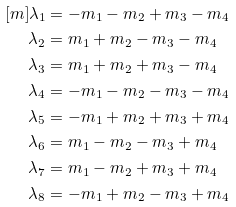Convert formula to latex. <formula><loc_0><loc_0><loc_500><loc_500>[ m ] \lambda _ { 1 } & = - m _ { 1 } - m _ { 2 } + m _ { 3 } - m _ { 4 } \\ \lambda _ { 2 } & = m _ { 1 } + m _ { 2 } - m _ { 3 } - m _ { 4 } \\ \lambda _ { 3 } & = m _ { 1 } + m _ { 2 } + m _ { 3 } - m _ { 4 } \\ \lambda _ { 4 } & = - m _ { 1 } - m _ { 2 } - m _ { 3 } - m _ { 4 } \\ \lambda _ { 5 } & = - m _ { 1 } + m _ { 2 } + m _ { 3 } + m _ { 4 } \\ \lambda _ { 6 } & = m _ { 1 } - m _ { 2 } - m _ { 3 } + m _ { 4 } \\ \lambda _ { 7 } & = m _ { 1 } - m _ { 2 } + m _ { 3 } + m _ { 4 } \\ \lambda _ { 8 } & = - m _ { 1 } + m _ { 2 } - m _ { 3 } + m _ { 4 } \\</formula> 